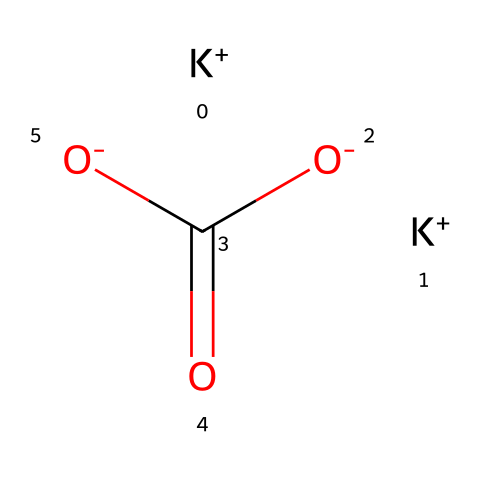What is the chemical formula of this compound? The molecular structure indicates the presence of two potassium atoms, one carbonate group consisting of one carbon and three oxygen atoms, which together forms the chemical formula K2CO3.
Answer: K2CO3 How many potassium atoms are present in the structure? The SMILES representation shows [K+] repeated twice, indicating there are two potassium atoms in the chemical structure.
Answer: 2 What type of bonding is observed in this molecule? The carbonate ion shows covalent bonding between carbon and oxygen atoms, while ionic bonding exists between potassium ions and the carbonate ion as potassium is a metal.
Answer: ionic and covalent What is the valence of the carbon atom in this structure? In the carbonate ion (C(=O)(O-)(O-)), carbon is double-bonded to one oxygen atom and single-bonded to two, which gives it a total of four bonds, corresponding to its tetravalent nature.
Answer: 4 What is the charge of the carbonate ion? The structure shows three oxygen atoms, two of which are negatively charged (O-) and one carbon atom forms a bond in the carbonate ion, leading to an overall charge of -2 for the carbonate ion (CO3^2-).
Answer: -2 Why is potassium carbonate classified as a superbase? Potassium carbonate can deprotonate weak acids due to the presence of strongly basic carbonate ions, making it an effective base in chemical reactions.
Answer: superbase How many oxygen atoms are present in potassium carbonate? In the carbonate ion (C(=O)(O-)(O-)), there are three oxygen atoms total based on the formula and structure.
Answer: 3 